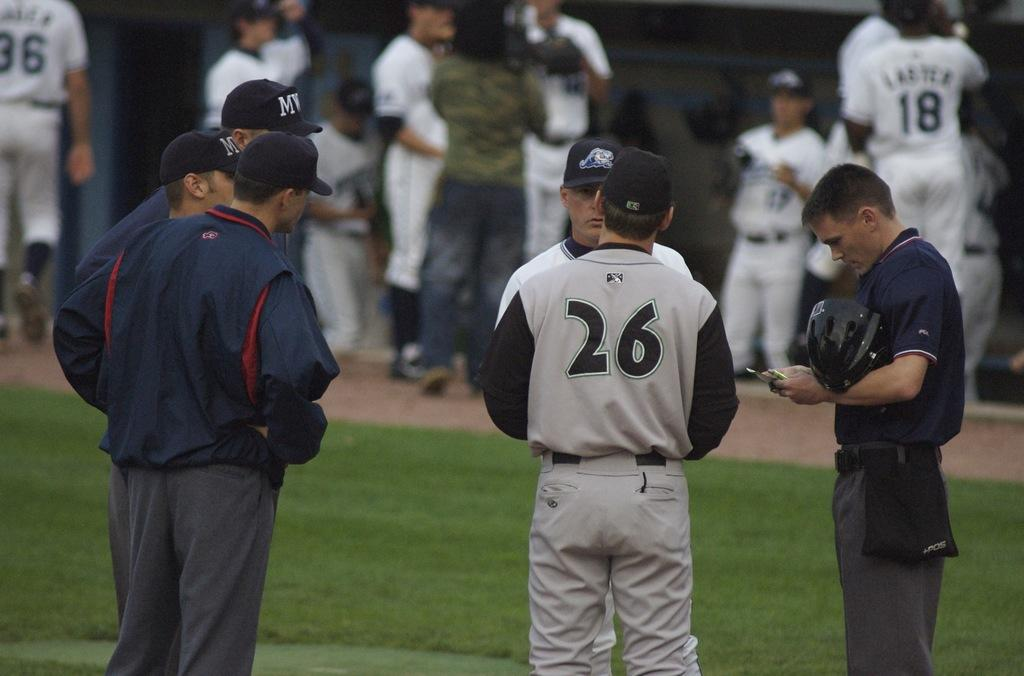Provide a one-sentence caption for the provided image. Baseball player number 26 is talking to another person and has his back to the camera. 